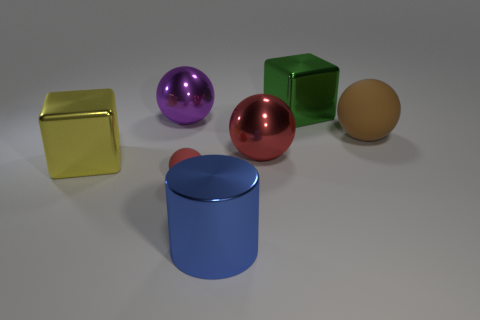The metallic thing that is the same color as the tiny ball is what size? The metallic thing that has the same purple hue as the small spherical object appears to be large, roughly the same size as the other geometric shapes in the image such as the cubes and the cylinder. 